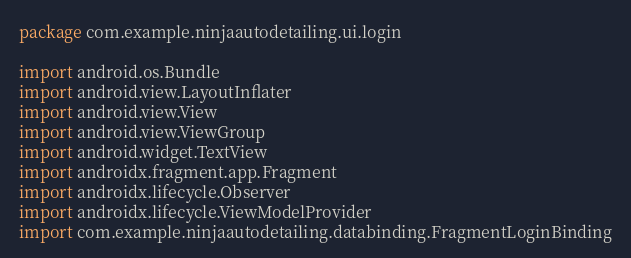Convert code to text. <code><loc_0><loc_0><loc_500><loc_500><_Kotlin_>package com.example.ninjaautodetailing.ui.login

import android.os.Bundle
import android.view.LayoutInflater
import android.view.View
import android.view.ViewGroup
import android.widget.TextView
import androidx.fragment.app.Fragment
import androidx.lifecycle.Observer
import androidx.lifecycle.ViewModelProvider
import com.example.ninjaautodetailing.databinding.FragmentLoginBinding
</code> 